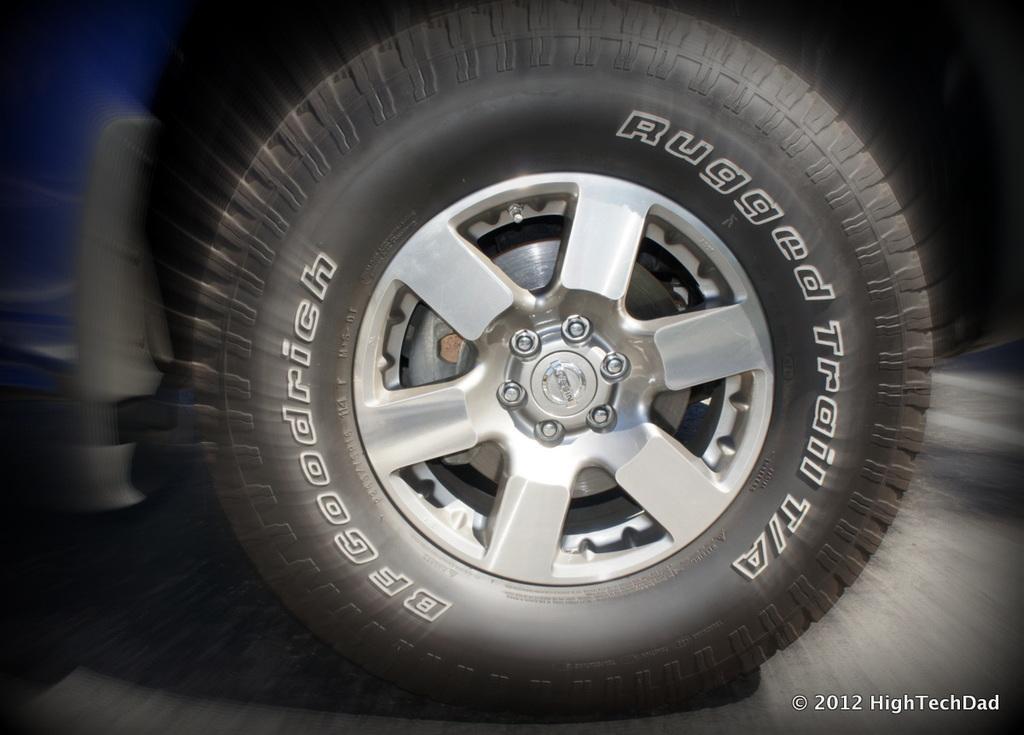In one or two sentences, can you explain what this image depicts? In the middle of the image there is a tyre. Around the tyre it is blurry. At the bottom right side of the image there is a watermark. 